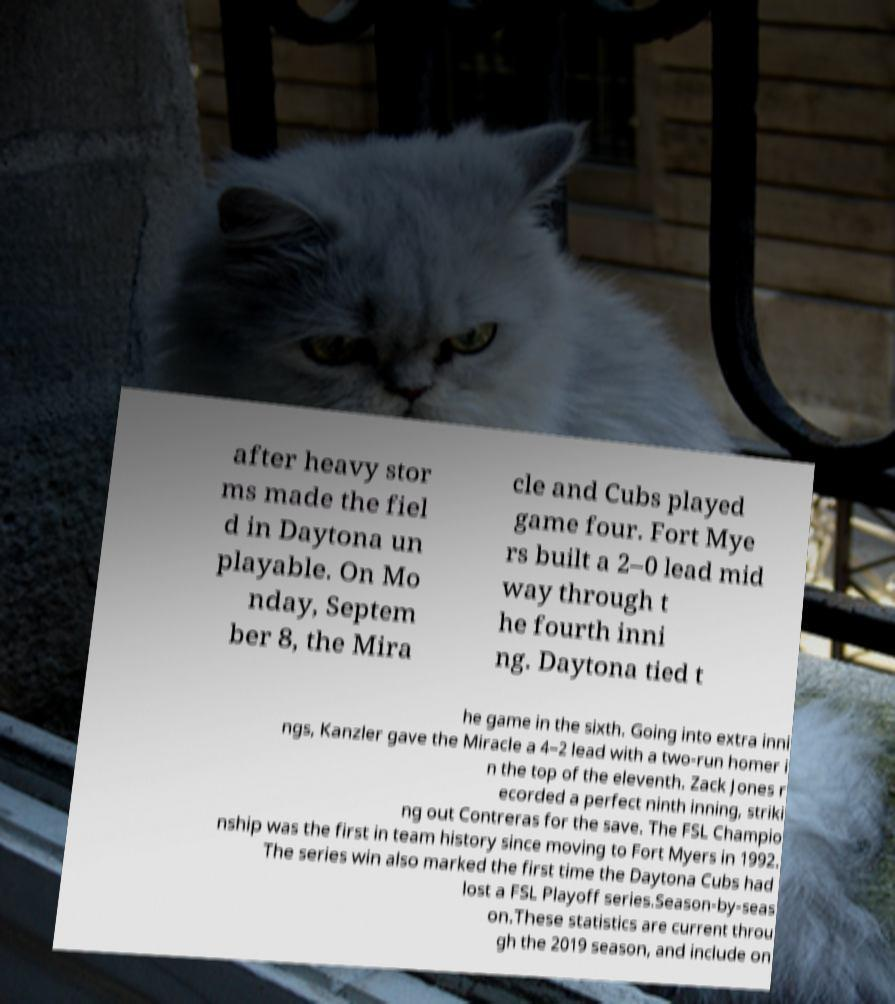There's text embedded in this image that I need extracted. Can you transcribe it verbatim? after heavy stor ms made the fiel d in Daytona un playable. On Mo nday, Septem ber 8, the Mira cle and Cubs played game four. Fort Mye rs built a 2–0 lead mid way through t he fourth inni ng. Daytona tied t he game in the sixth. Going into extra inni ngs, Kanzler gave the Miracle a 4–2 lead with a two-run homer i n the top of the eleventh. Zack Jones r ecorded a perfect ninth inning, striki ng out Contreras for the save. The FSL Champio nship was the first in team history since moving to Fort Myers in 1992. The series win also marked the first time the Daytona Cubs had lost a FSL Playoff series.Season-by-seas on.These statistics are current throu gh the 2019 season, and include on 